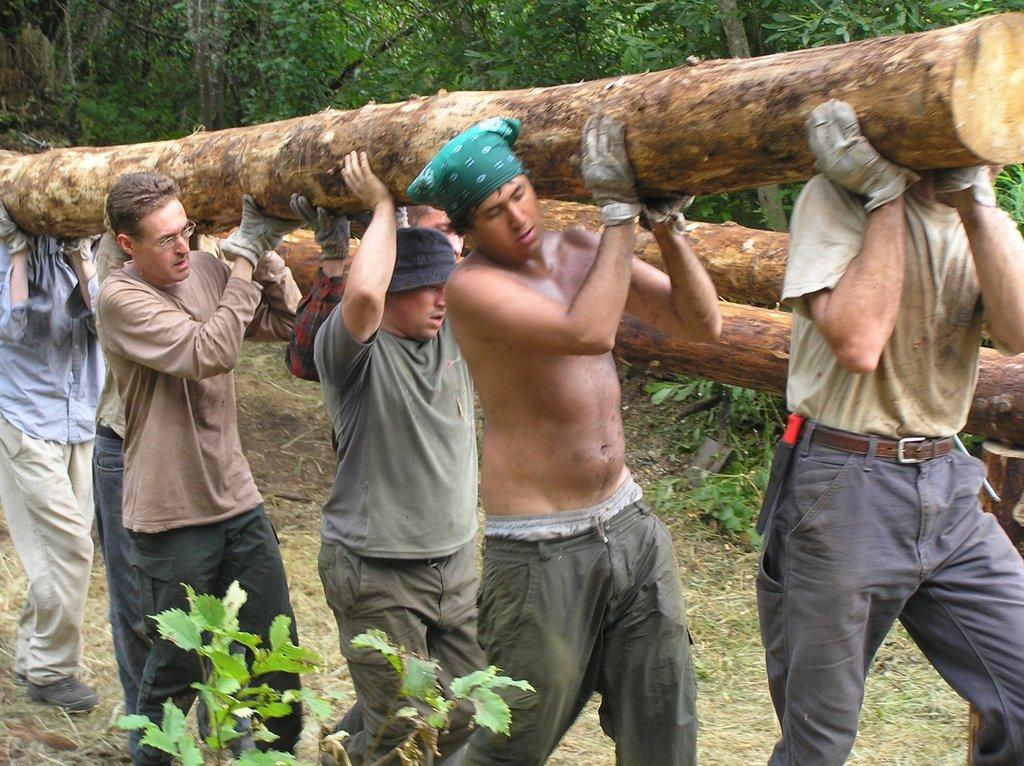What are the men in the image doing? The men in the image are walking on the land and carrying wooden logs. What can be seen in the background of the image? There are trees in the background of the image. What is visible in the front of the image? There is a plant visible in the front of the image. What type of cough can be heard from the monkey in the image? There is no monkey present in the image, and therefore no cough can be heard. Is there a tiger visible in the image? No, there is no tiger visible in the image. 